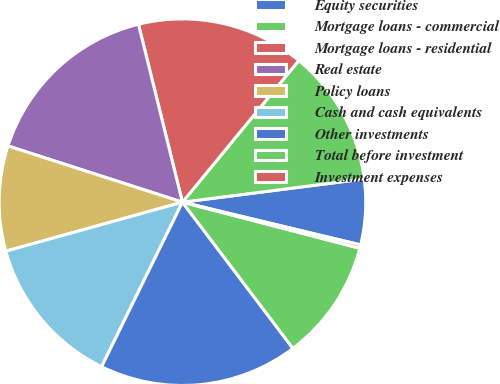Convert chart. <chart><loc_0><loc_0><loc_500><loc_500><pie_chart><fcel>Equity securities<fcel>Mortgage loans - commercial<fcel>Mortgage loans - residential<fcel>Real estate<fcel>Policy loans<fcel>Cash and cash equivalents<fcel>Other investments<fcel>Total before investment<fcel>Investment expenses<nl><fcel>5.77%<fcel>12.03%<fcel>14.8%<fcel>16.18%<fcel>9.27%<fcel>13.42%<fcel>17.57%<fcel>10.65%<fcel>0.3%<nl></chart> 